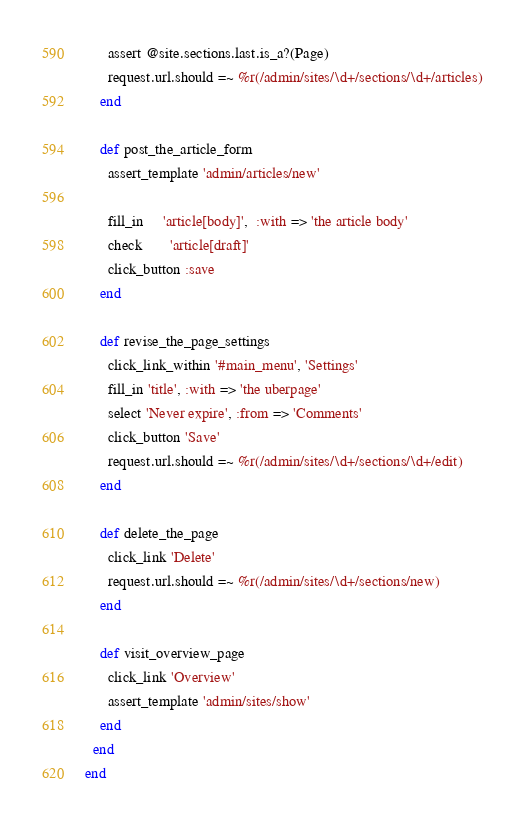Convert code to text. <code><loc_0><loc_0><loc_500><loc_500><_Ruby_>      assert @site.sections.last.is_a?(Page)
      request.url.should =~ %r(/admin/sites/\d+/sections/\d+/articles)
    end
    
    def post_the_article_form
      assert_template 'admin/articles/new'
      
      fill_in     'article[body]',  :with => 'the article body'
      check       'article[draft]'
      click_button :save
    end

    def revise_the_page_settings
      click_link_within '#main_menu', 'Settings'
      fill_in 'title', :with => 'the uberpage'
      select 'Never expire', :from => 'Comments'
      click_button 'Save'
      request.url.should =~ %r(/admin/sites/\d+/sections/\d+/edit)
    end

    def delete_the_page
      click_link 'Delete'
      request.url.should =~ %r(/admin/sites/\d+/sections/new)
    end
    
    def visit_overview_page
      click_link 'Overview'
      assert_template 'admin/sites/show'
    end
  end
end</code> 